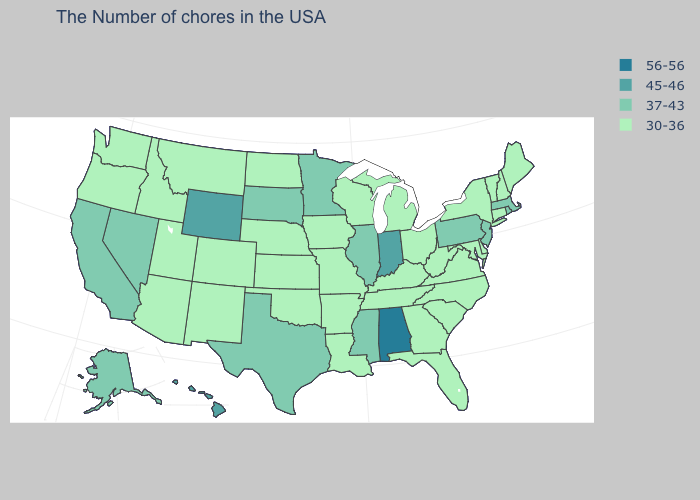Which states have the highest value in the USA?
Answer briefly. Alabama. What is the value of California?
Short answer required. 37-43. Which states have the lowest value in the USA?
Quick response, please. Maine, New Hampshire, Vermont, Connecticut, New York, Delaware, Maryland, Virginia, North Carolina, South Carolina, West Virginia, Ohio, Florida, Georgia, Michigan, Kentucky, Tennessee, Wisconsin, Louisiana, Missouri, Arkansas, Iowa, Kansas, Nebraska, Oklahoma, North Dakota, Colorado, New Mexico, Utah, Montana, Arizona, Idaho, Washington, Oregon. What is the value of Georgia?
Write a very short answer. 30-36. What is the value of Delaware?
Answer briefly. 30-36. What is the value of South Carolina?
Answer briefly. 30-36. What is the value of Wyoming?
Write a very short answer. 45-46. Is the legend a continuous bar?
Quick response, please. No. Among the states that border Rhode Island , which have the lowest value?
Be succinct. Connecticut. Which states have the highest value in the USA?
Answer briefly. Alabama. What is the value of Wyoming?
Keep it brief. 45-46. Does Oregon have the lowest value in the West?
Give a very brief answer. Yes. What is the highest value in the South ?
Give a very brief answer. 56-56. What is the value of Minnesota?
Short answer required. 37-43. Name the states that have a value in the range 45-46?
Quick response, please. Indiana, Wyoming, Hawaii. 